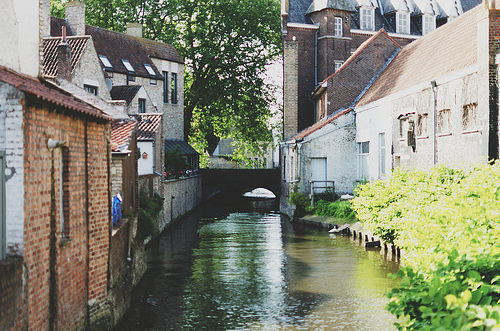<image>
Can you confirm if the channel is in front of the house? Yes. The channel is positioned in front of the house, appearing closer to the camera viewpoint. 